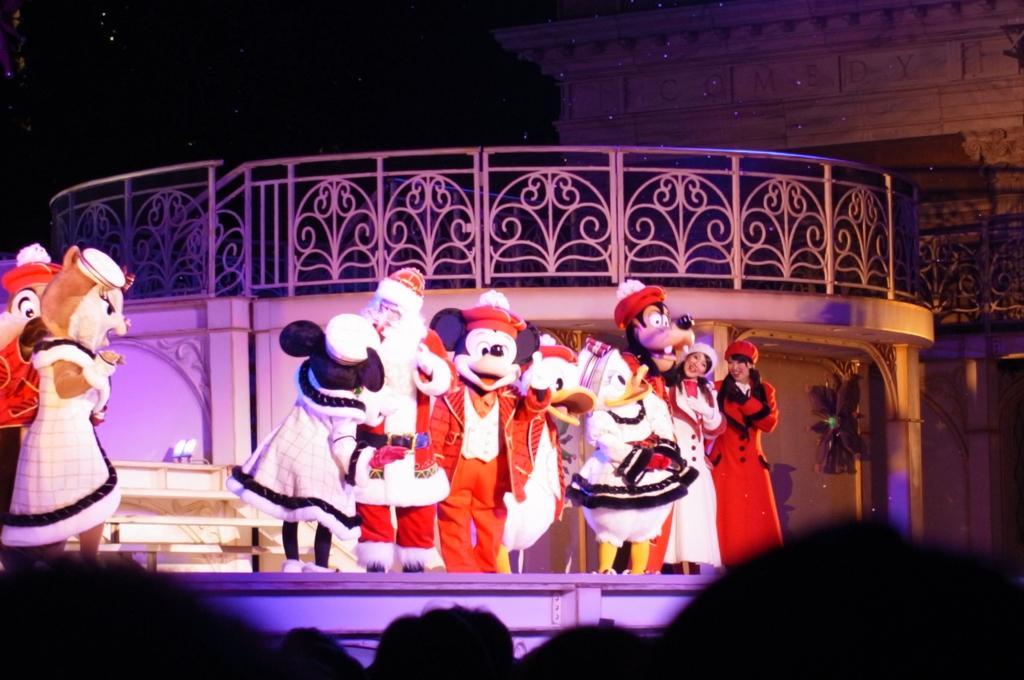Describe this image in one or two sentences. In this picture we can see a group of people in the fancy dresses and the people are standing on the stage. Behind the people there are some objects and iron grilles. Behind the grilles, it looks like a wall. 